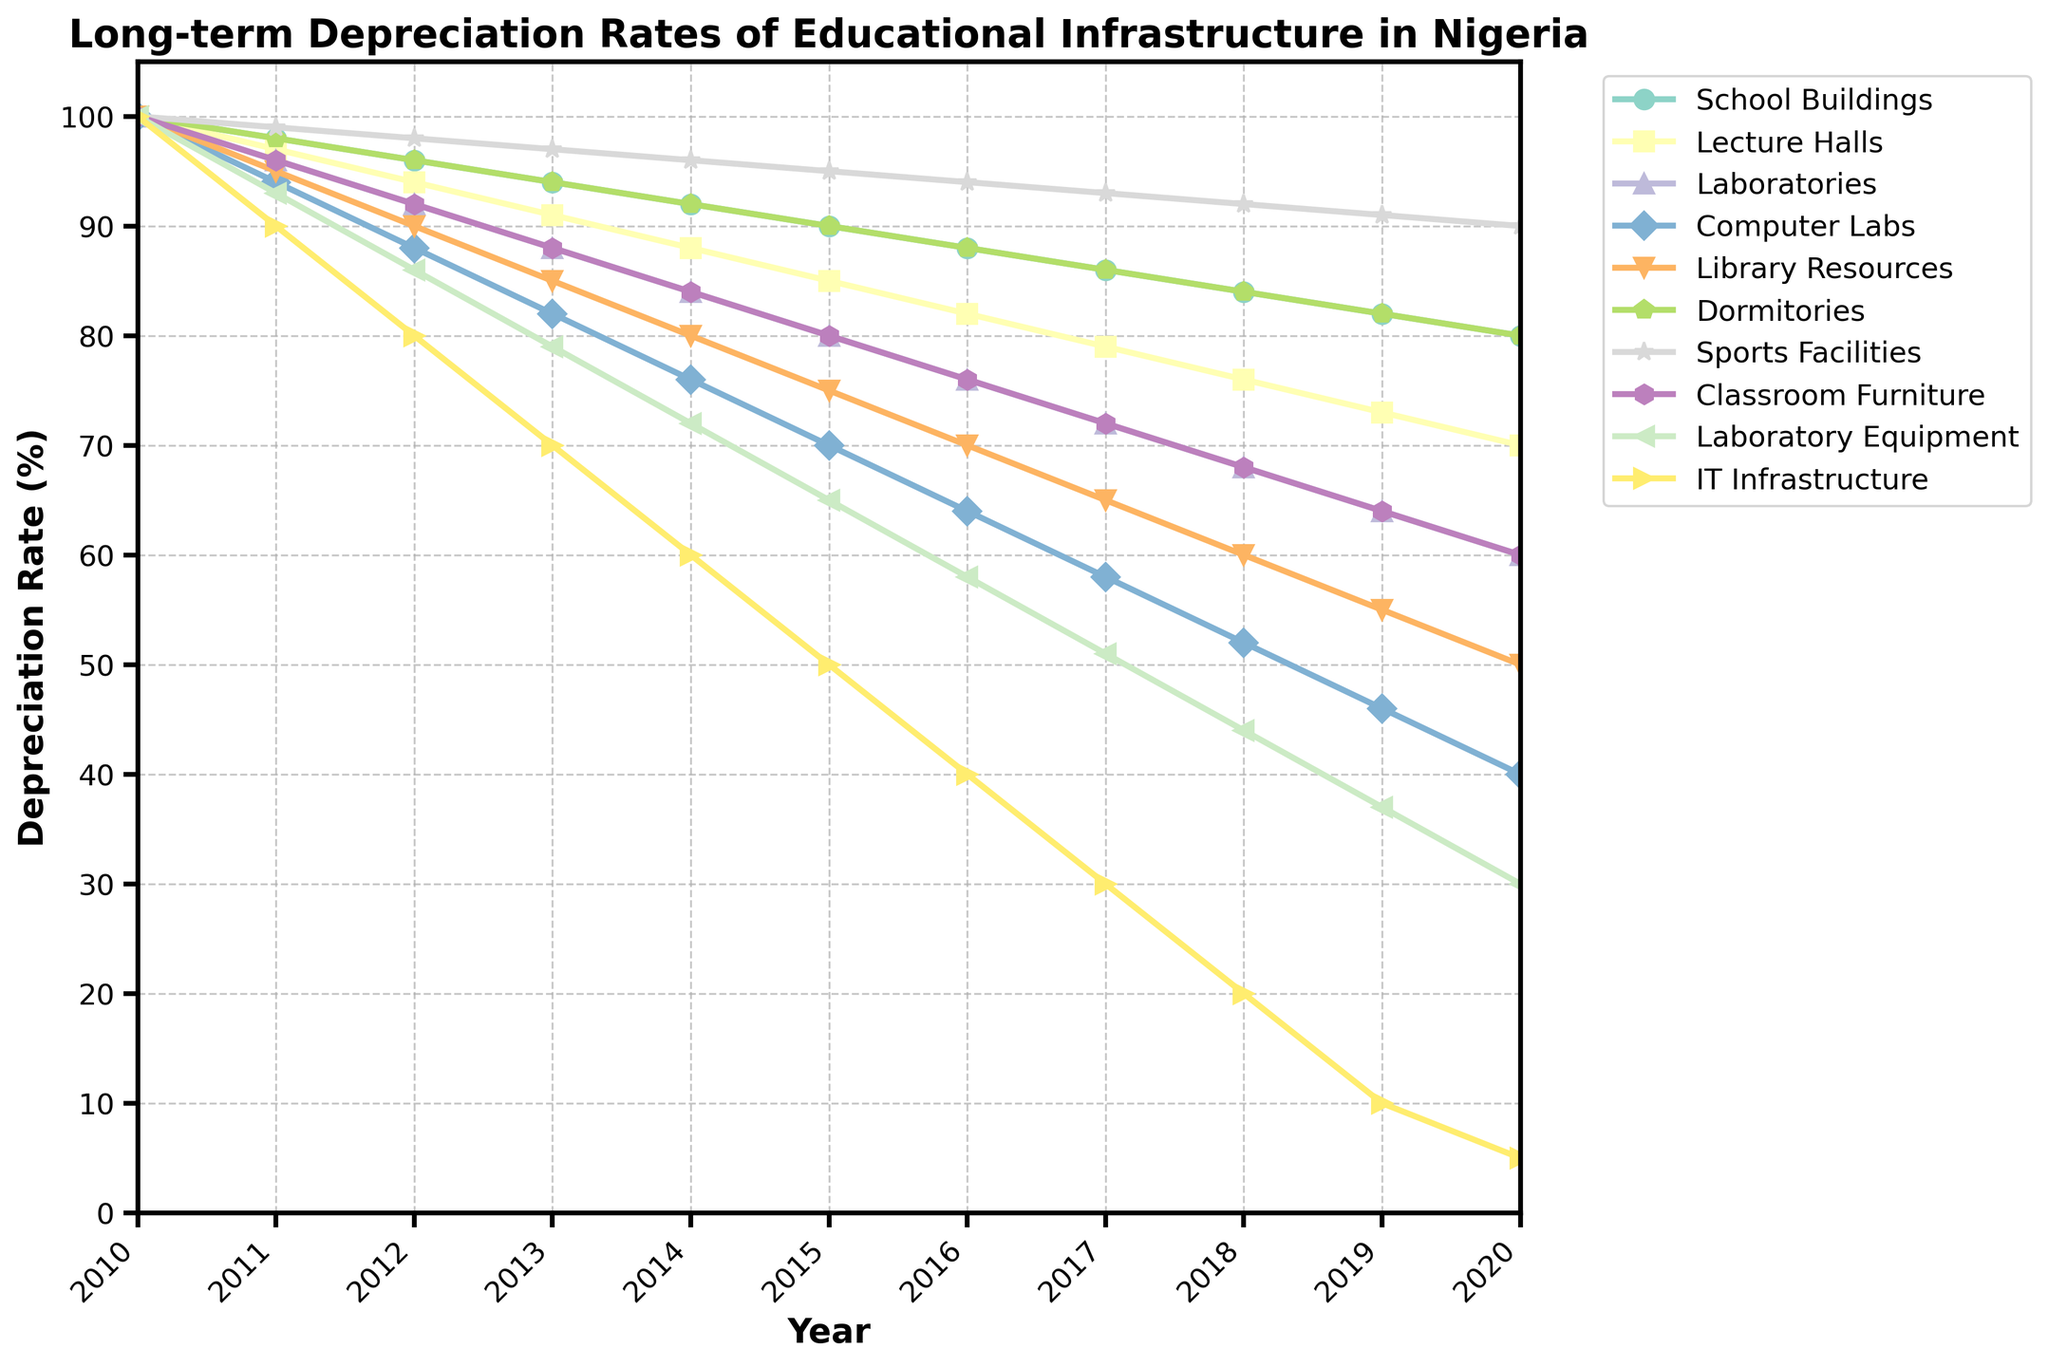Which type of infrastructure deteriorated the most by 2020? By visually inspecting the ending values of all infrastructure types in 2020, IT Infrastructure shows the steepest decline, reaching a depreciation rate of 5%.
Answer: IT Infrastructure How did the depreciation rate of Laboratories change from 2010 to 2015? The depreciation rate of Laboratories started at 100% in 2010 and dropped to 80% by 2015. This was a decrease of 20 percentage points.
Answer: Decreased by 20 percentage points By 2015, which two types of infrastructure had approximately the same depreciation rate? In 2015, Lecture Halls and Laboratories both had depreciation rates close to each other, at 85% and 80%, respectively.
Answer: Lecture Halls and Laboratories What is the average depreciation rate of Sports Facilities from 2017 to 2020? The depreciation rates of Sports Facilities are 93%, 92%, 91%, and 90% for 2017, 2018, 2019, and 2020, respectively. Summing these gives 366%. Dividing by 4 yields an average of 91.5%.
Answer: 91.5% Which infrastructure type had the lowest depreciation rate in 2018? By examining the data for 2018, Sports Facilities had the highest remaining percentage at 92%.
Answer: Sports Facilities How much did the depreciation rate of Computer Labs decline from 2011 to 2013? The depreciation rate of Computer Labs was 94% in 2011 and fell to 82% in 2013. The difference is 94 - 82 = 12%.
Answer: 12% Which infrastructure types had a depreciation rate below 50% by 2019? In 2019, the depreciation rates for Library Resources and IT Infrastructure are 46% and 10% respectively. Both are below 50%.
Answer: Library Resources and IT Infrastructure In which year did Dormitories and Classroom Furniture have the same depreciation rate? Comparing year by year, in 2012, both Dormitories and Classroom Furniture had a depreciation rate of 96%.
Answer: 2012 How many years did it take for the depreciation rate of Laboratory Equipment to drop below 50%? Laboratory Equipment started at 100% in 2010 and declined to 44% in 2018, taking 8 years to drop below 50%.
Answer: 8 years In the year 2014, which infrastructure had a depreciation rate closest to 80%? In 2014, Lecture Halls had a depreciation rate of 88%, which is the closest to 80%, compared to other types.
Answer: Lecture Halls 